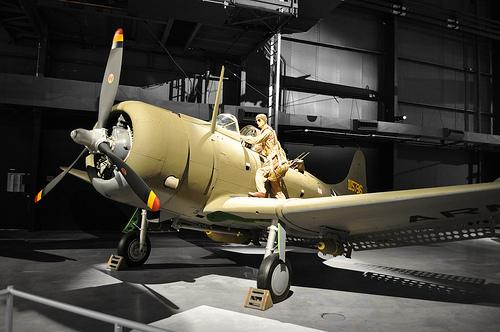Describe any human figure present in the image and their interaction with the object. A mannequin dressed in a pilot uniform is climbing into the antique airplane. Explain the position of the mannequin and its relationship to the plane. The mannequin is standing on the wing of the plane, presumably acting as a pilot for the antique airplane. Is there any lettering on the airplane? If yes, mention its color and location. Yes, there is large black lettering on the bottom of the wing. Mention any unusual color patterns on the propeller. Red, yellow, and black stripes are present on the tip of the propeller. Identify and describe the overall setting of the image. The setting is an airplane hangar with an antique airplane, mannequin, and various equipment and tools inside. Identify the primary object in the image and mention its color. An old-fashioned beige airplane with a black propeller is the primary object in the image. What type of building structure can be found in the image? There are two-story garage doors in the image. What is the color of the wedge stopping the plane from moving, and where is it positioned? The wooden wheel wedge is tan and is positioned under the landing wheel of the airplane. List any equipment or tools present in the image. A steel ladder, wheel stop blocks, and a grey guard railing are present in the image. What is the approximate number of wheels present in the image? There are approximately three wheels visible in the image. 